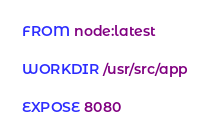<code> <loc_0><loc_0><loc_500><loc_500><_Dockerfile_>FROM node:latest

WORKDIR /usr/src/app

EXPOSE 8080
</code> 